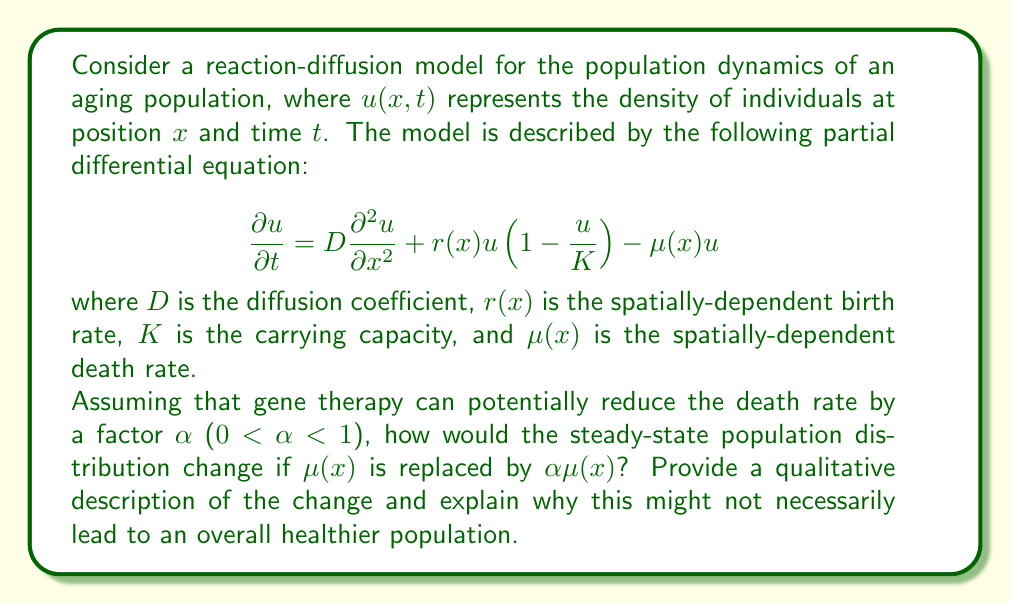Show me your answer to this math problem. To analyze this problem, we need to consider the steady-state solution of the reaction-diffusion equation. At steady-state, $\frac{\partial u}{\partial t} = 0$, so the equation becomes:

$$D\frac{\partial^2 u}{\partial x^2} + r(x)u(1-\frac{u}{K}) - \mu(x)u = 0$$

1. Original steady-state:
   The population will distribute itself such that the diffusion, birth, and death terms balance each other. The steady-state distribution will depend on the spatial variation of $r(x)$ and $\mu(x)$.

2. Modified steady-state with gene therapy:
   Replacing $\mu(x)$ with $\alpha\mu(x)$, the steady-state equation becomes:

   $$D\frac{\partial^2 u}{\partial x^2} + r(x)u(1-\frac{u}{K}) - \alpha\mu(x)u = 0$$

3. Qualitative analysis of the change:
   a. The reduced death rate will generally lead to an increase in the steady-state population density.
   b. The spatial distribution may shift, with relatively higher population densities in areas where the death rate was previously limiting the population.
   c. The carrying capacity $K$ will become a more dominant factor in limiting population growth.

4. Why this might not lead to an overall healthier population:
   a. Increased population density may lead to more competition for resources, potentially reducing the quality of life for individuals.
   b. The gene therapy might not address underlying causes of aging-related diseases, merely prolonging life without improving health.
   c. The altered population dynamics might lead to unforeseen consequences in the ecosystem or society, such as increased strain on healthcare systems or environmental resources.
   d. The spatial redistribution of the population might lead to overcrowding in certain areas, potentially increasing the risk of disease transmission or reducing access to essential services.

From a pharmaceutical executive's perspective, this analysis highlights the potential limitations and unintended consequences of gene therapy as a treatment for aging diseases. It suggests that a more holistic approach, considering population-level effects and quality of life, might be necessary when developing treatments for aging-related conditions.
Answer: The steady-state population distribution will generally increase in density, with potentially significant shifts in spatial distribution favoring areas where death rates were previously limiting. However, this change may not necessarily result in an overall healthier population due to increased resource competition, potential overcrowding, and unaddressed underlying causes of aging-related diseases. 